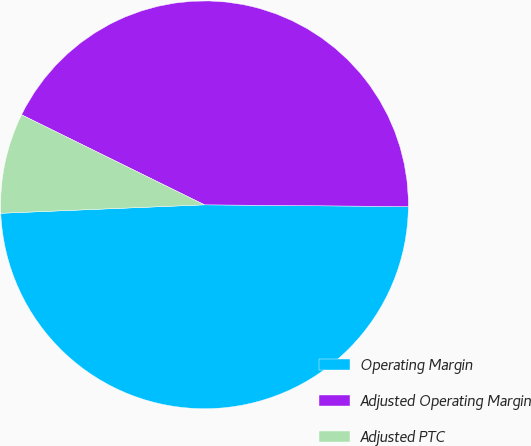<chart> <loc_0><loc_0><loc_500><loc_500><pie_chart><fcel>Operating Margin<fcel>Adjusted Operating Margin<fcel>Adjusted PTC<nl><fcel>49.21%<fcel>42.86%<fcel>7.94%<nl></chart> 